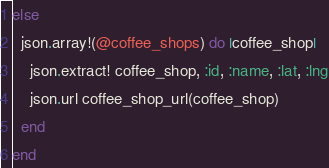Convert code to text. <code><loc_0><loc_0><loc_500><loc_500><_Ruby_>else
  json.array!(@coffee_shops) do |coffee_shop|
    json.extract! coffee_shop, :id, :name, :lat, :lng
    json.url coffee_shop_url(coffee_shop)
  end
end
</code> 